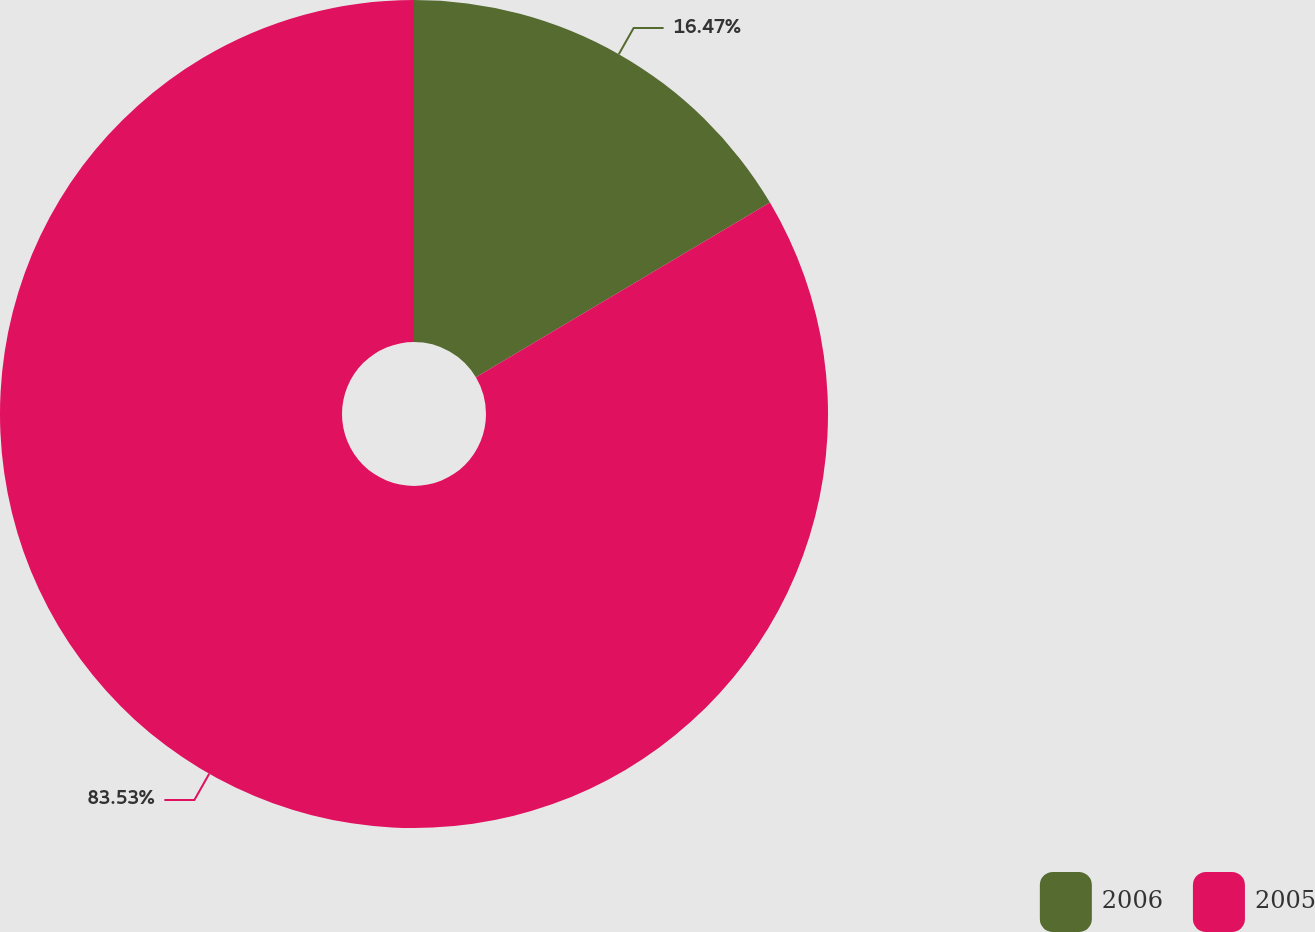Convert chart to OTSL. <chart><loc_0><loc_0><loc_500><loc_500><pie_chart><fcel>2006<fcel>2005<nl><fcel>16.47%<fcel>83.53%<nl></chart> 